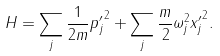<formula> <loc_0><loc_0><loc_500><loc_500>H = \sum _ { j } \frac { 1 } { 2 m } { p _ { j } ^ { \prime } } ^ { 2 } + \sum _ { j } \frac { m } { 2 } \omega _ { j } ^ { 2 } { x _ { j } ^ { \prime } } ^ { 2 } .</formula> 